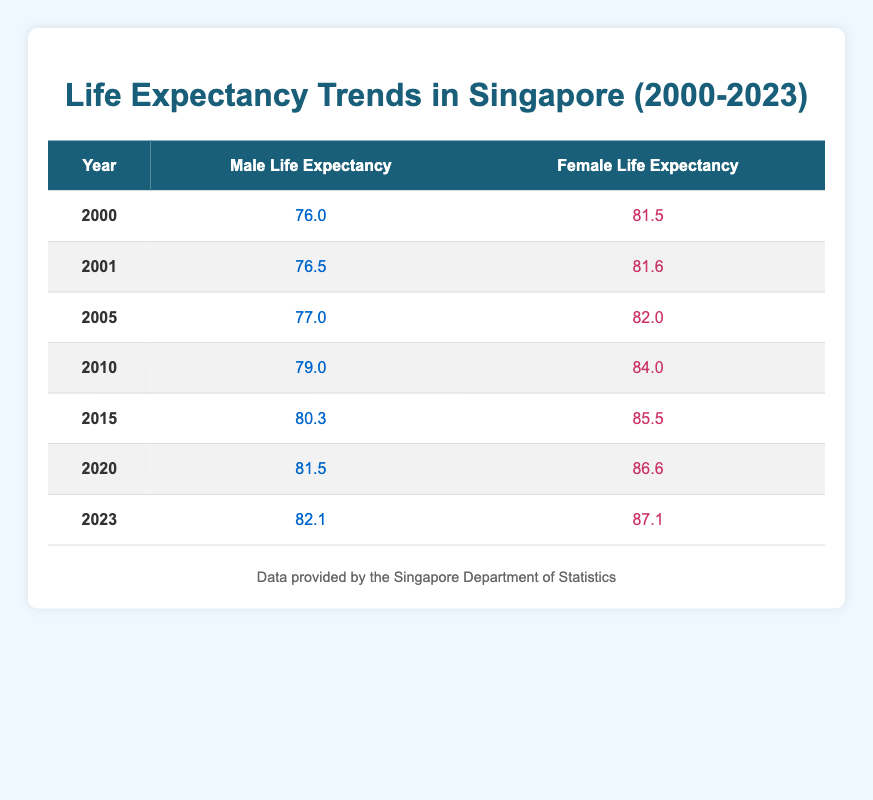What was the life expectancy for males in 2010? Referring to the row for the year 2010 in the table, the value for male life expectancy is listed as 79.0.
Answer: 79.0 What was the life expectancy for females in 2023? Looking at the row for the year 2023, the female life expectancy is provided as 87.1.
Answer: 87.1 In what year did male life expectancy first exceed 80 years? By examining the table, we see that male life expectancy reached 80.3 in 2015, which is the first instance above 80 years.
Answer: 2015 What is the difference in life expectancy between males and females in 2020? For the year 2020, male life expectancy is 81.5 and female life expectancy is 86.6. Subtracting these values gives us 86.6 - 81.5 = 5.1.
Answer: 5.1 What have been the trends in female life expectancy from 2000 to 2023? To analyze trends, we look at the female life expectancy values provided in the table: 81.5 in 2000, increasing to 87.1 in 2023. This shows a consistent increase over the years.
Answer: Increasing Are there any years where male life expectancy was equal to or greater than female life expectancy? By checking each year in the table, we find that male life expectancy was never equal to or greater than female life expectancy in any given year listed from 2000 to 2023.
Answer: No What is the average male life expectancy over the years 2000 to 2023? To find the average male life expectancy, we sum the values for each year: (76.0 + 76.5 + 77.0 + 79.0 + 80.3 + 81.5 + 82.1) = 476.4. There are 7 data points, so the average is 476.4 / 7 = 68.057.
Answer: 68.057 How much has the female life expectancy increased from 2000 to 2023? Looking at the values for the years, female life expectancy in 2000 was 81.5 and in 2023 it was 87.1. To find the increase, we subtract: 87.1 - 81.5 = 5.6 years.
Answer: 5.6 What is the trend in life expectancy for males from 2000 to 2023? Evaluating the data from the table, we see a clear upward trend as male life expectancy has increased from 76.0 in 2000 to 82.1 in 2023.
Answer: Increasing 